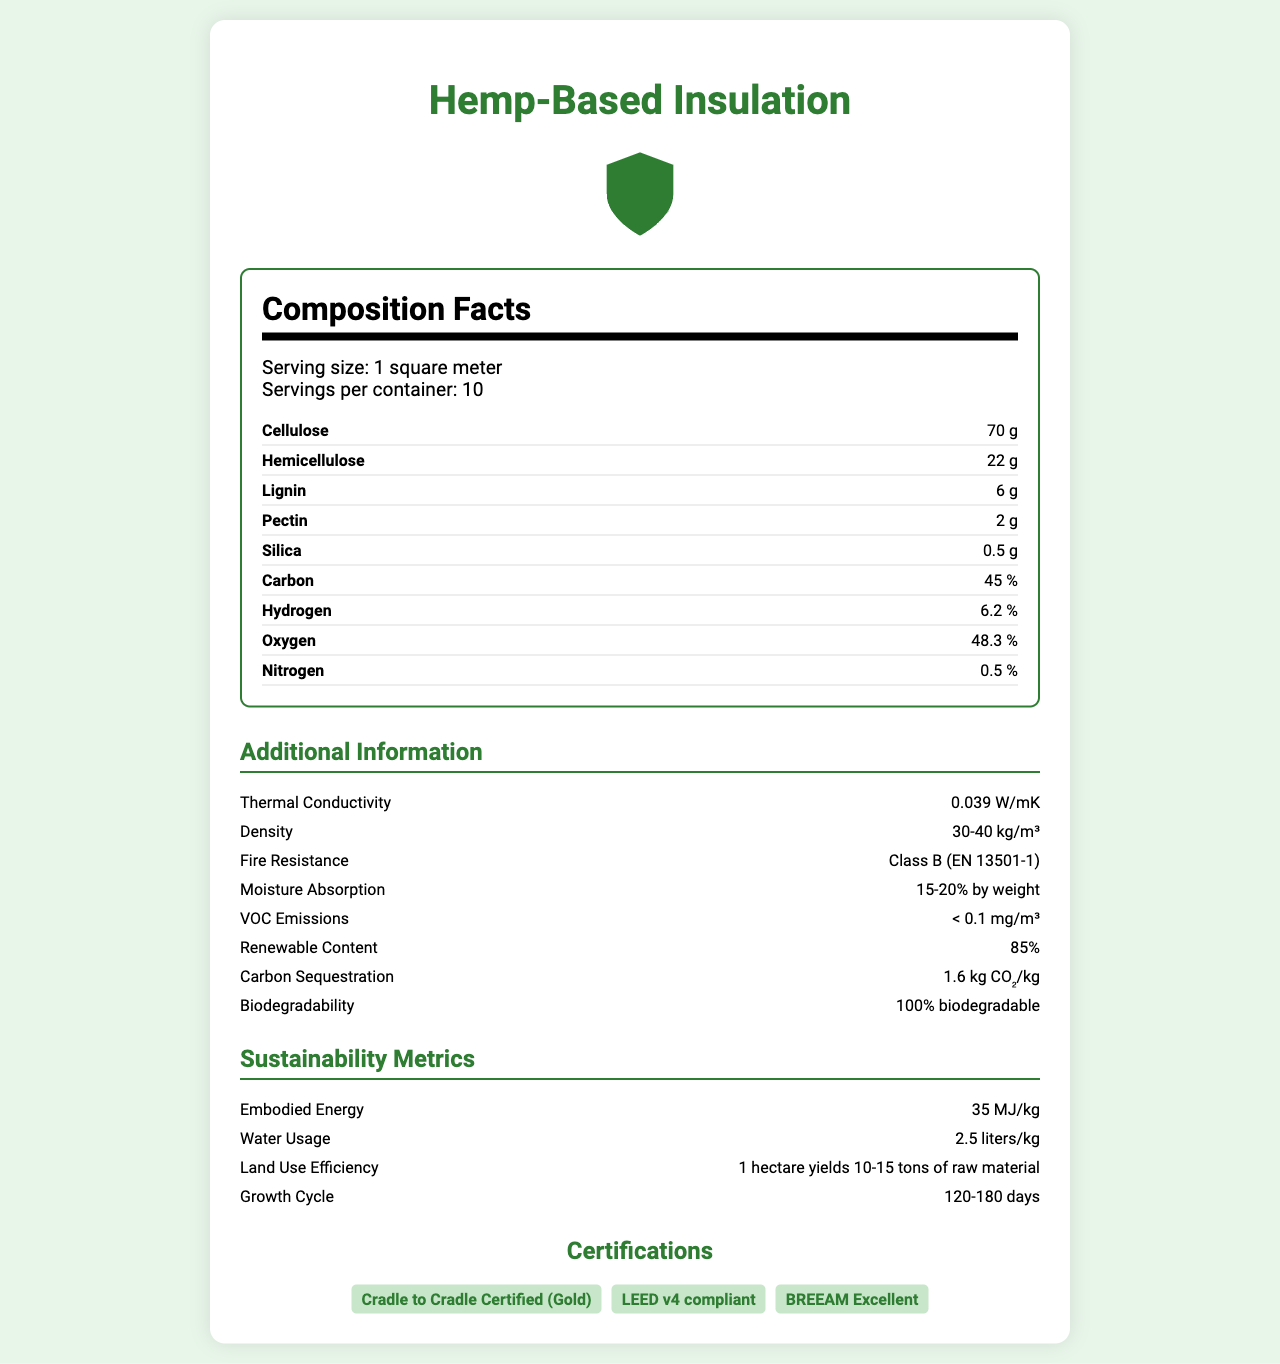what is the serving size of the hemp-based insulation? The document states that the serving size is 1 square meter.
Answer: 1 square meter how much cellulose is there in one serving of the product? The document lists cellulose as one of the nutrients and mentions its amount as 70 grams per serving.
Answer: 70 grams what is the thermal conductivity of this hemp-based insulation? The Additional Information section specifies that the product has a thermal conductivity of 0.039 W/mK.
Answer: 0.039 W/mK which certification(s) does the product have? The Certifications section lists these three certifications.
Answer: Cradle to Cradle Certified (Gold), LEED v4 compliant, BREEAM Excellent is the product biodegradable? The Additional Information clearly states that the product is 100% biodegradable.
Answer: Yes what is the renewable content of the product? The Additional Information section mentions the renewable content as 85%.
Answer: 85% how long is the growth cycle for the raw material used in this product? The Sustainability Metrics section lists the growth cycle as 120-180 days.
Answer: 120-180 days what is the moisture absorption capacity of the insulation? The Additional Information section specifies moisture absorption as 15-20% by weight.
Answer: 15-20% by weight how much carbon sequestration does the product achieve per kilogram? The Additional Information section states that the product achieves 1.6 kg CO₂/kg for carbon sequestration.
Answer: 1.6 kg CO₂/kg what is the density range of the hemp-based insulation? The Additional Information section provides the density range as 30-40 kg/m³.
Answer: 30-40 kg/m³ what percentage of the insulation material is made up of carbon? The nutrients list shows carbon at 45%.
Answer: 45% what is the fire resistance class of the product according to EN 13501-1? A. Class A B. Class B C. Class C D. Class D The Additional Information section states the fire resistance class as Class B based on EN 13501-1.
Answer: B how much embodied energy does the hemp-based insulation use? A. 25 MJ/kg B. 30 MJ/kg C. 35 MJ/kg D. 40 MJ/kg The Sustainability Metrics section states that the embodied energy is 35 MJ/kg.
Answer: C is the nutrient composition of the insulation material provided on a percentage basis? Only carbon, hydrogen, oxygen, and nitrogen are provided as percentages; other nutrients like cellulose, hemicellulose, lignin, and pectin are provided in grams.
Answer: No summarize the main idea of the document. This summary captures the nutritional and additional technical properties, along with sustainability metrics and certifications, of the hemp-based insulation.
Answer: The document provides detailed information on the nutrient composition, additional properties, sustainability metrics, and certifications of a hemp-based insulation product. It includes key data such as serving size, the amount of various nutrients, thermal conductivity, density, fire resistance, moisture absorption, VOC emissions, renewable content, carbon sequestration, and biodegradability. The document also covers embodied energy, water usage, land use efficiency, and growth cycle of the raw material. what is the water usage for the production of the hemp-based insulation? The Sustainability Metrics section lists water usage as 2.5 liters/kg.
Answer: 2.5 liters/kg does the document mention the cost per serving of the hemp-based insulation? The document does not provide any information regarding the cost per serving of the insulation.
Answer: Not enough information 